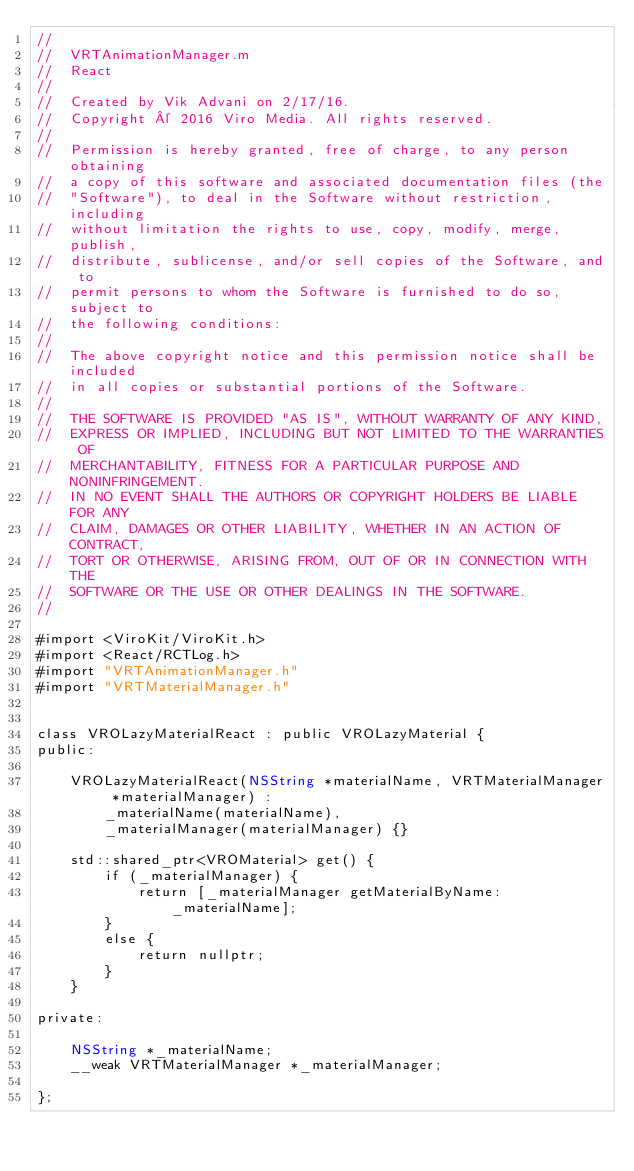<code> <loc_0><loc_0><loc_500><loc_500><_ObjectiveC_>//
//  VRTAnimationManager.m
//  React
//
//  Created by Vik Advani on 2/17/16.
//  Copyright © 2016 Viro Media. All rights reserved.
//
//  Permission is hereby granted, free of charge, to any person obtaining
//  a copy of this software and associated documentation files (the
//  "Software"), to deal in the Software without restriction, including
//  without limitation the rights to use, copy, modify, merge, publish,
//  distribute, sublicense, and/or sell copies of the Software, and to
//  permit persons to whom the Software is furnished to do so, subject to
//  the following conditions:
//
//  The above copyright notice and this permission notice shall be included
//  in all copies or substantial portions of the Software.
//
//  THE SOFTWARE IS PROVIDED "AS IS", WITHOUT WARRANTY OF ANY KIND,
//  EXPRESS OR IMPLIED, INCLUDING BUT NOT LIMITED TO THE WARRANTIES OF
//  MERCHANTABILITY, FITNESS FOR A PARTICULAR PURPOSE AND NONINFRINGEMENT.
//  IN NO EVENT SHALL THE AUTHORS OR COPYRIGHT HOLDERS BE LIABLE FOR ANY
//  CLAIM, DAMAGES OR OTHER LIABILITY, WHETHER IN AN ACTION OF CONTRACT,
//  TORT OR OTHERWISE, ARISING FROM, OUT OF OR IN CONNECTION WITH THE
//  SOFTWARE OR THE USE OR OTHER DEALINGS IN THE SOFTWARE.
//

#import <ViroKit/ViroKit.h>
#import <React/RCTLog.h>
#import "VRTAnimationManager.h"
#import "VRTMaterialManager.h"


class VROLazyMaterialReact : public VROLazyMaterial {
public:
    
    VROLazyMaterialReact(NSString *materialName, VRTMaterialManager *materialManager) :
        _materialName(materialName),
        _materialManager(materialManager) {}
    
    std::shared_ptr<VROMaterial> get() {
        if (_materialManager) {
            return [_materialManager getMaterialByName:_materialName];
        }
        else {
            return nullptr;
        }
    }
    
private:
    
    NSString *_materialName;
    __weak VRTMaterialManager *_materialManager;
    
};
</code> 